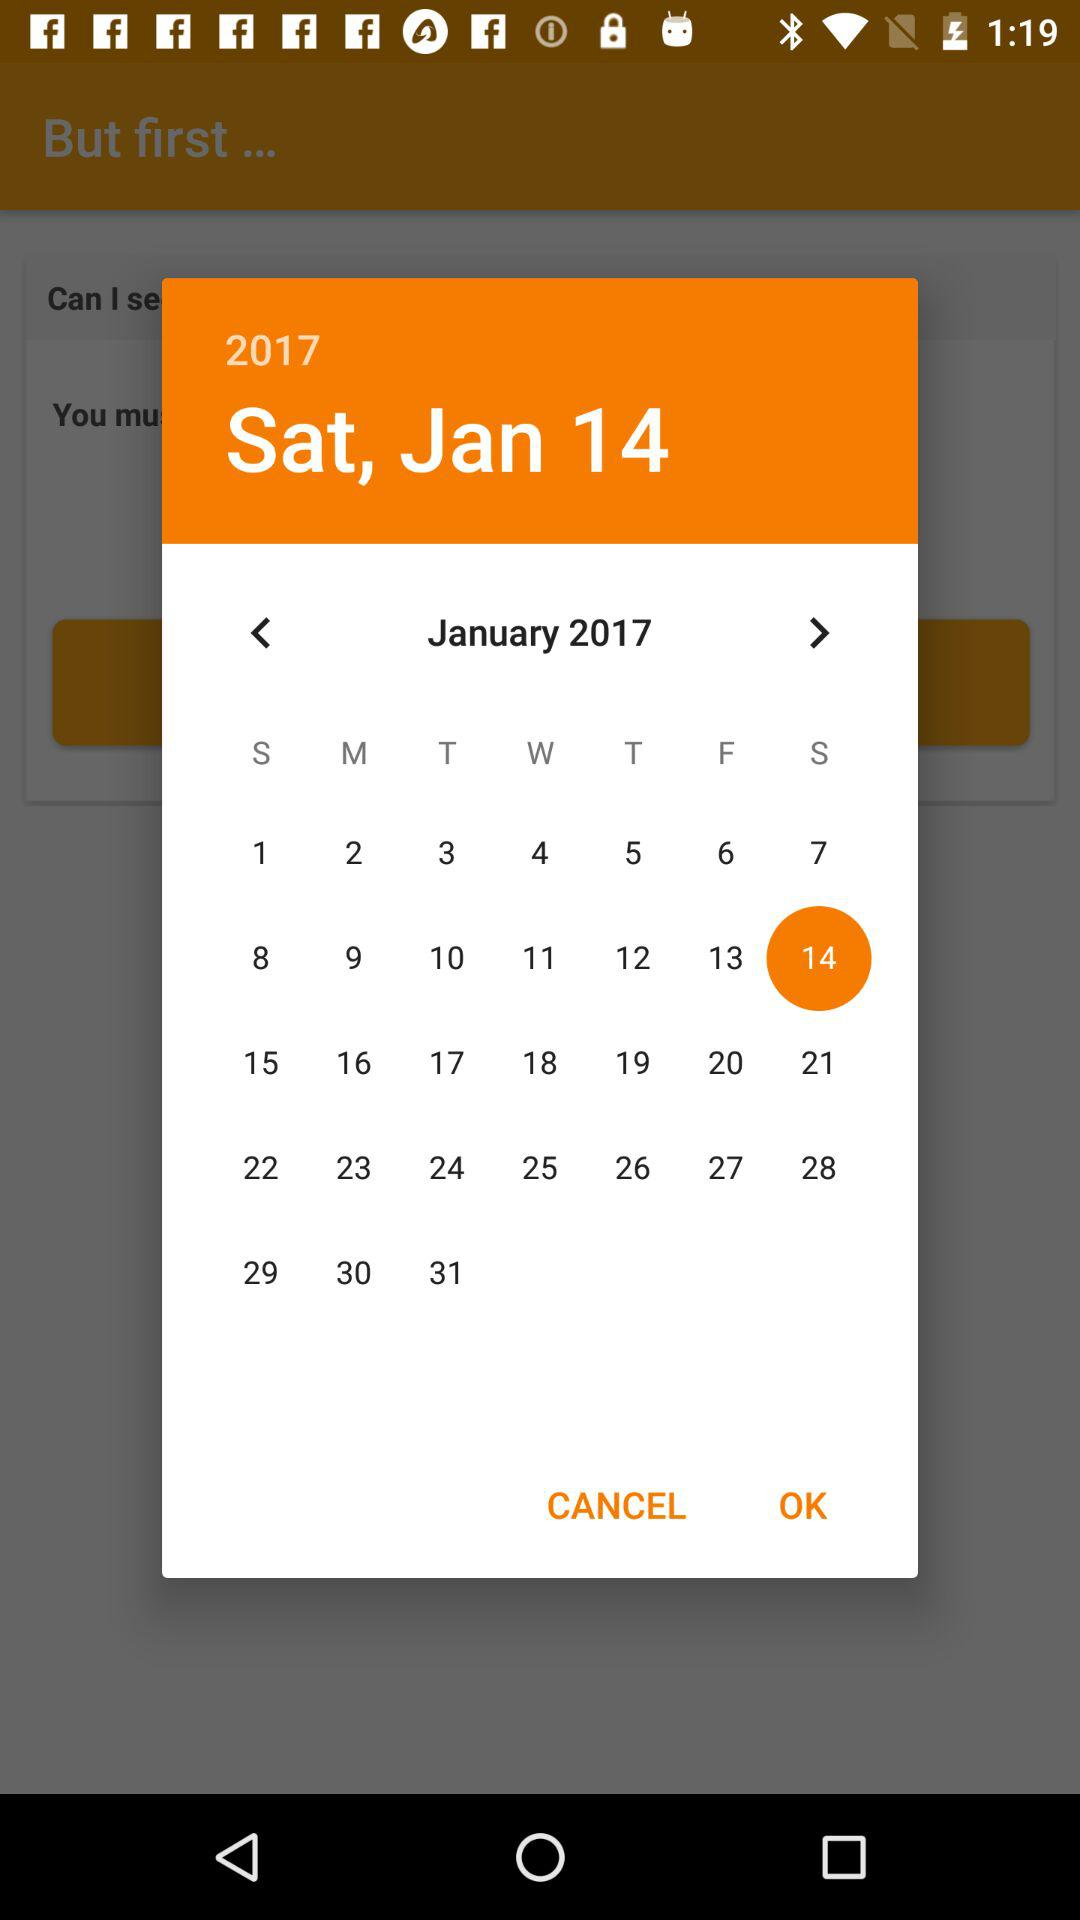What is the day on 14 January 2017? The day is Saturday. 